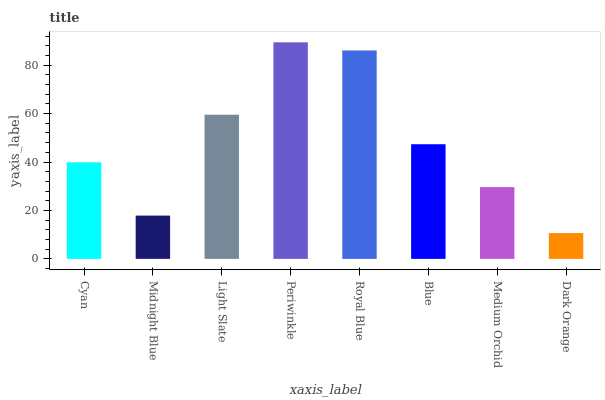Is Dark Orange the minimum?
Answer yes or no. Yes. Is Periwinkle the maximum?
Answer yes or no. Yes. Is Midnight Blue the minimum?
Answer yes or no. No. Is Midnight Blue the maximum?
Answer yes or no. No. Is Cyan greater than Midnight Blue?
Answer yes or no. Yes. Is Midnight Blue less than Cyan?
Answer yes or no. Yes. Is Midnight Blue greater than Cyan?
Answer yes or no. No. Is Cyan less than Midnight Blue?
Answer yes or no. No. Is Blue the high median?
Answer yes or no. Yes. Is Cyan the low median?
Answer yes or no. Yes. Is Cyan the high median?
Answer yes or no. No. Is Blue the low median?
Answer yes or no. No. 